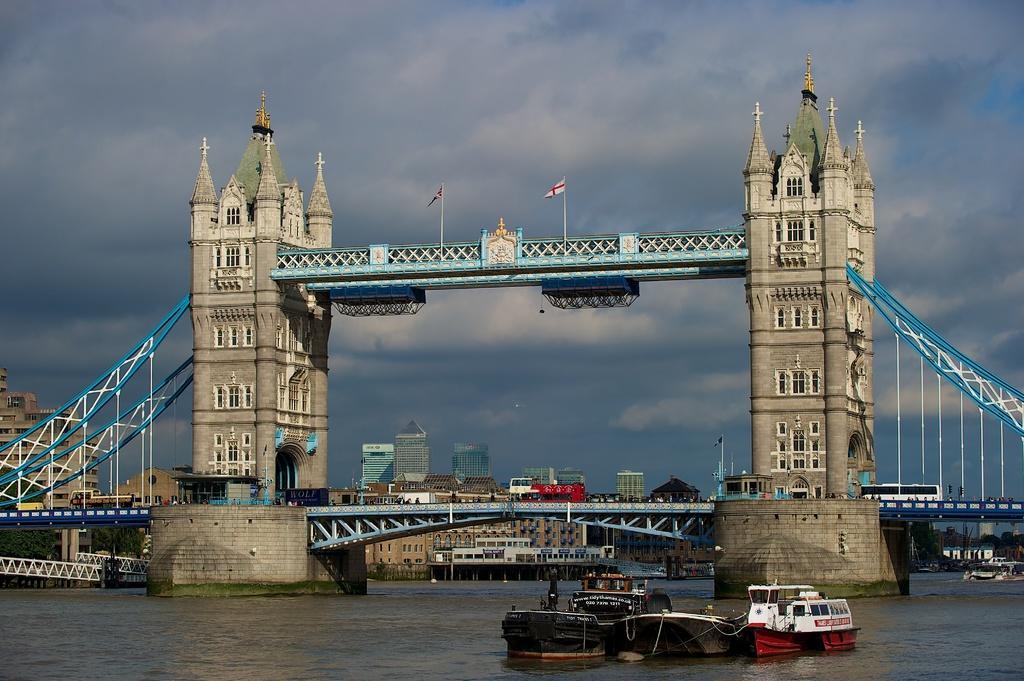Can you describe this image briefly? In this picture there is a bridge in the foreground and there are flags and their vehicles on the bridge. At the back there are buildings and trees. In the foreground there are boats on the water. At the top there is sky and there are clouds. At the bottom there is water. 